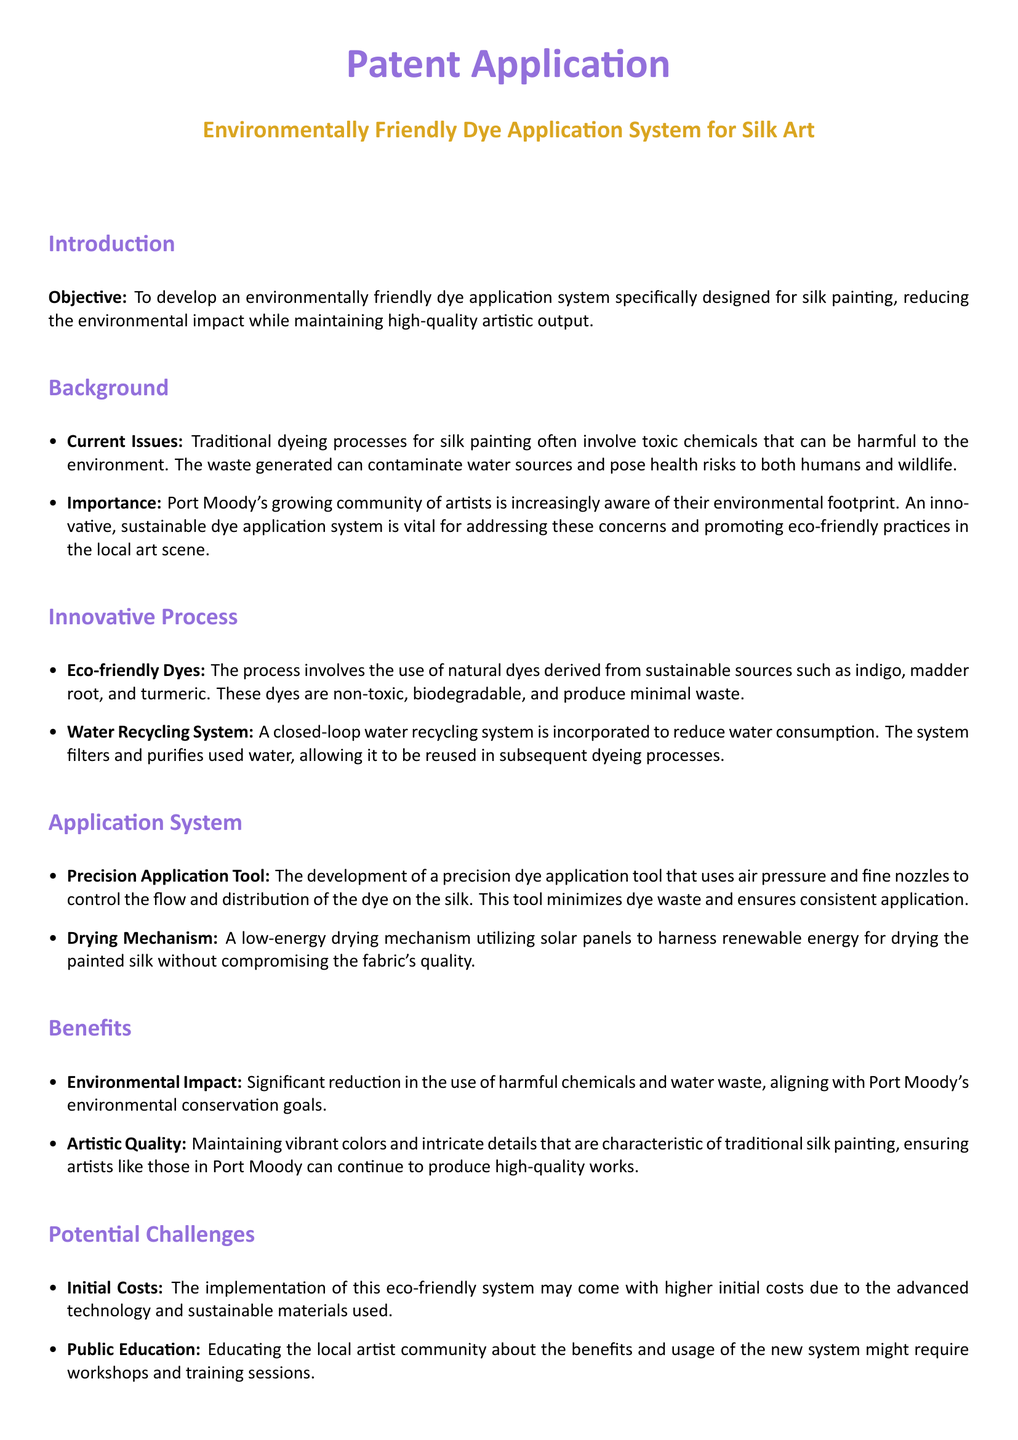What is the objective of the patent application? The objective is to develop an environmentally friendly dye application system specifically designed for silk painting.
Answer: To develop an environmentally friendly dye application system for silk painting What are the natural dyes mentioned? The natural dyes mentioned are derived from sustainable sources such as indigo, madder root, and turmeric.
Answer: Indigo, madder root, turmeric What system is incorporated to reduce water consumption? A closed-loop water recycling system is incorporated to reduce water consumption.
Answer: Closed-loop water recycling system What renewable energy source is used for drying silk? A low-energy drying mechanism utilizing solar panels is used for drying painted silk.
Answer: Solar panels What is a potential challenge mentioned in the document? A potential challenge is the initial costs of implementing the eco-friendly system.
Answer: Initial costs What is the color associated with the document's title? The color associated with the document’s title is silk gold.
Answer: Silk gold What type of tool is developed for dye application? The developed tool is a precision dye application tool.
Answer: Precision dye application tool What is the environmental impact of the proposed system? The environmental impact includes significant reduction in the use of harmful chemicals and water waste.
Answer: Significant reduction in harmful chemicals and water waste What is the primary focus of the artist community in Port Moody regarding dye application? The primary focus is on reducing environmental impact while maintaining high-quality artistic output.
Answer: Reducing environmental impact while maintaining high-quality artistic output 